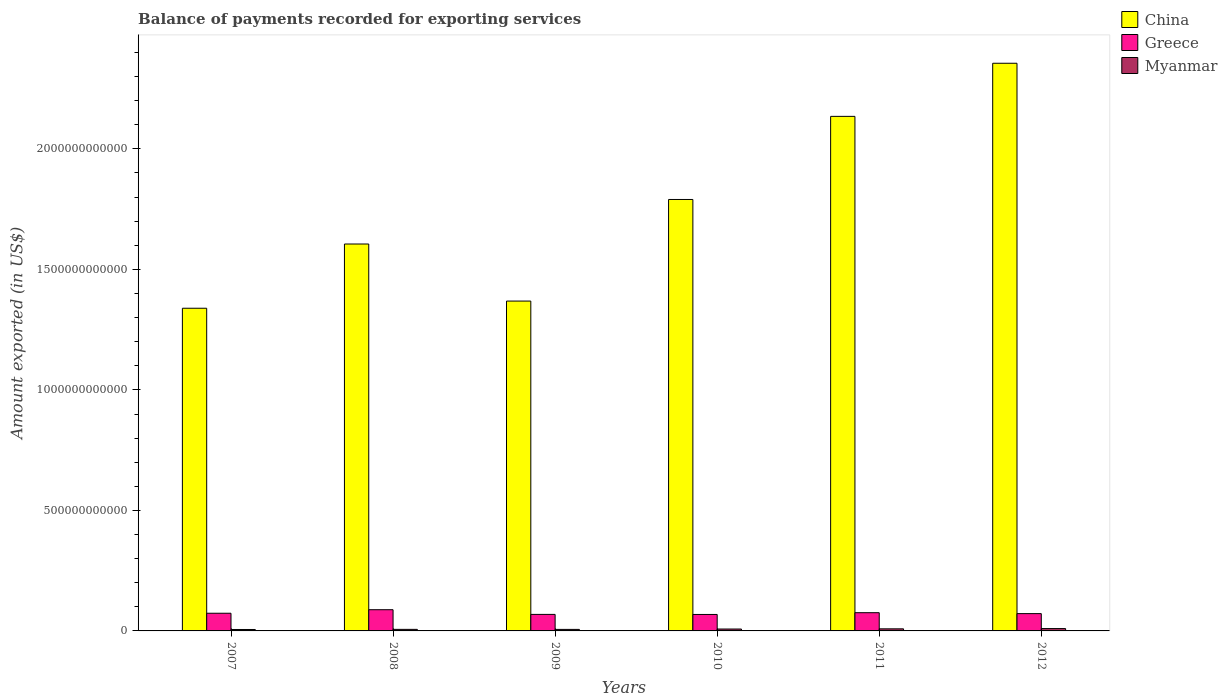Are the number of bars per tick equal to the number of legend labels?
Your answer should be compact. Yes. How many bars are there on the 5th tick from the left?
Make the answer very short. 3. What is the label of the 6th group of bars from the left?
Your answer should be compact. 2012. In how many cases, is the number of bars for a given year not equal to the number of legend labels?
Give a very brief answer. 0. What is the amount exported in Greece in 2012?
Ensure brevity in your answer.  7.18e+1. Across all years, what is the maximum amount exported in Greece?
Make the answer very short. 8.80e+1. Across all years, what is the minimum amount exported in China?
Offer a terse response. 1.34e+12. In which year was the amount exported in China maximum?
Keep it short and to the point. 2012. What is the total amount exported in China in the graph?
Your answer should be compact. 1.06e+13. What is the difference between the amount exported in China in 2007 and that in 2008?
Your response must be concise. -2.67e+11. What is the difference between the amount exported in Greece in 2007 and the amount exported in China in 2009?
Offer a very short reply. -1.30e+12. What is the average amount exported in China per year?
Your answer should be very brief. 1.77e+12. In the year 2009, what is the difference between the amount exported in China and amount exported in Greece?
Your answer should be compact. 1.30e+12. In how many years, is the amount exported in Greece greater than 600000000000 US$?
Ensure brevity in your answer.  0. What is the ratio of the amount exported in Greece in 2010 to that in 2011?
Your answer should be compact. 0.9. Is the amount exported in Myanmar in 2011 less than that in 2012?
Make the answer very short. Yes. What is the difference between the highest and the second highest amount exported in Greece?
Provide a short and direct response. 1.24e+1. What is the difference between the highest and the lowest amount exported in China?
Provide a succinct answer. 1.02e+12. In how many years, is the amount exported in China greater than the average amount exported in China taken over all years?
Offer a terse response. 3. What does the 3rd bar from the left in 2012 represents?
Offer a very short reply. Myanmar. What does the 3rd bar from the right in 2007 represents?
Your answer should be very brief. China. Is it the case that in every year, the sum of the amount exported in China and amount exported in Myanmar is greater than the amount exported in Greece?
Ensure brevity in your answer.  Yes. Are all the bars in the graph horizontal?
Make the answer very short. No. What is the difference between two consecutive major ticks on the Y-axis?
Offer a very short reply. 5.00e+11. Are the values on the major ticks of Y-axis written in scientific E-notation?
Your answer should be compact. No. How many legend labels are there?
Give a very brief answer. 3. How are the legend labels stacked?
Your answer should be very brief. Vertical. What is the title of the graph?
Your answer should be very brief. Balance of payments recorded for exporting services. What is the label or title of the X-axis?
Your answer should be very brief. Years. What is the label or title of the Y-axis?
Ensure brevity in your answer.  Amount exported (in US$). What is the Amount exported (in US$) of China in 2007?
Keep it short and to the point. 1.34e+12. What is the Amount exported (in US$) of Greece in 2007?
Keep it short and to the point. 7.34e+1. What is the Amount exported (in US$) of Myanmar in 2007?
Make the answer very short. 5.91e+09. What is the Amount exported (in US$) in China in 2008?
Your answer should be very brief. 1.61e+12. What is the Amount exported (in US$) of Greece in 2008?
Provide a succinct answer. 8.80e+1. What is the Amount exported (in US$) in Myanmar in 2008?
Your answer should be compact. 6.44e+09. What is the Amount exported (in US$) of China in 2009?
Your answer should be very brief. 1.37e+12. What is the Amount exported (in US$) of Greece in 2009?
Offer a very short reply. 6.85e+1. What is the Amount exported (in US$) in Myanmar in 2009?
Your response must be concise. 6.35e+09. What is the Amount exported (in US$) of China in 2010?
Your answer should be very brief. 1.79e+12. What is the Amount exported (in US$) of Greece in 2010?
Give a very brief answer. 6.83e+1. What is the Amount exported (in US$) in Myanmar in 2010?
Your answer should be very brief. 7.85e+09. What is the Amount exported (in US$) of China in 2011?
Your answer should be very brief. 2.13e+12. What is the Amount exported (in US$) in Greece in 2011?
Your answer should be very brief. 7.56e+1. What is the Amount exported (in US$) in Myanmar in 2011?
Make the answer very short. 8.66e+09. What is the Amount exported (in US$) of China in 2012?
Keep it short and to the point. 2.36e+12. What is the Amount exported (in US$) in Greece in 2012?
Offer a terse response. 7.18e+1. What is the Amount exported (in US$) in Myanmar in 2012?
Your response must be concise. 9.74e+09. Across all years, what is the maximum Amount exported (in US$) of China?
Ensure brevity in your answer.  2.36e+12. Across all years, what is the maximum Amount exported (in US$) of Greece?
Give a very brief answer. 8.80e+1. Across all years, what is the maximum Amount exported (in US$) in Myanmar?
Offer a terse response. 9.74e+09. Across all years, what is the minimum Amount exported (in US$) in China?
Provide a succinct answer. 1.34e+12. Across all years, what is the minimum Amount exported (in US$) of Greece?
Give a very brief answer. 6.83e+1. Across all years, what is the minimum Amount exported (in US$) of Myanmar?
Ensure brevity in your answer.  5.91e+09. What is the total Amount exported (in US$) in China in the graph?
Provide a succinct answer. 1.06e+13. What is the total Amount exported (in US$) of Greece in the graph?
Offer a very short reply. 4.46e+11. What is the total Amount exported (in US$) of Myanmar in the graph?
Your response must be concise. 4.50e+1. What is the difference between the Amount exported (in US$) of China in 2007 and that in 2008?
Your response must be concise. -2.67e+11. What is the difference between the Amount exported (in US$) of Greece in 2007 and that in 2008?
Provide a succinct answer. -1.46e+1. What is the difference between the Amount exported (in US$) in Myanmar in 2007 and that in 2008?
Ensure brevity in your answer.  -5.28e+08. What is the difference between the Amount exported (in US$) of China in 2007 and that in 2009?
Your answer should be compact. -2.97e+1. What is the difference between the Amount exported (in US$) in Greece in 2007 and that in 2009?
Your answer should be compact. 4.86e+09. What is the difference between the Amount exported (in US$) of Myanmar in 2007 and that in 2009?
Keep it short and to the point. -4.36e+08. What is the difference between the Amount exported (in US$) in China in 2007 and that in 2010?
Keep it short and to the point. -4.51e+11. What is the difference between the Amount exported (in US$) of Greece in 2007 and that in 2010?
Offer a terse response. 5.07e+09. What is the difference between the Amount exported (in US$) of Myanmar in 2007 and that in 2010?
Give a very brief answer. -1.94e+09. What is the difference between the Amount exported (in US$) of China in 2007 and that in 2011?
Your answer should be compact. -7.96e+11. What is the difference between the Amount exported (in US$) of Greece in 2007 and that in 2011?
Provide a succinct answer. -2.21e+09. What is the difference between the Amount exported (in US$) of Myanmar in 2007 and that in 2011?
Keep it short and to the point. -2.75e+09. What is the difference between the Amount exported (in US$) in China in 2007 and that in 2012?
Offer a terse response. -1.02e+12. What is the difference between the Amount exported (in US$) of Greece in 2007 and that in 2012?
Keep it short and to the point. 1.61e+09. What is the difference between the Amount exported (in US$) of Myanmar in 2007 and that in 2012?
Keep it short and to the point. -3.83e+09. What is the difference between the Amount exported (in US$) in China in 2008 and that in 2009?
Offer a terse response. 2.37e+11. What is the difference between the Amount exported (in US$) in Greece in 2008 and that in 2009?
Offer a terse response. 1.95e+1. What is the difference between the Amount exported (in US$) of Myanmar in 2008 and that in 2009?
Your answer should be very brief. 9.17e+07. What is the difference between the Amount exported (in US$) in China in 2008 and that in 2010?
Ensure brevity in your answer.  -1.85e+11. What is the difference between the Amount exported (in US$) of Greece in 2008 and that in 2010?
Your response must be concise. 1.97e+1. What is the difference between the Amount exported (in US$) of Myanmar in 2008 and that in 2010?
Make the answer very short. -1.41e+09. What is the difference between the Amount exported (in US$) of China in 2008 and that in 2011?
Ensure brevity in your answer.  -5.30e+11. What is the difference between the Amount exported (in US$) in Greece in 2008 and that in 2011?
Make the answer very short. 1.24e+1. What is the difference between the Amount exported (in US$) of Myanmar in 2008 and that in 2011?
Provide a succinct answer. -2.22e+09. What is the difference between the Amount exported (in US$) in China in 2008 and that in 2012?
Your response must be concise. -7.50e+11. What is the difference between the Amount exported (in US$) in Greece in 2008 and that in 2012?
Give a very brief answer. 1.62e+1. What is the difference between the Amount exported (in US$) in Myanmar in 2008 and that in 2012?
Your response must be concise. -3.31e+09. What is the difference between the Amount exported (in US$) in China in 2009 and that in 2010?
Offer a very short reply. -4.22e+11. What is the difference between the Amount exported (in US$) of Greece in 2009 and that in 2010?
Provide a short and direct response. 2.10e+08. What is the difference between the Amount exported (in US$) of Myanmar in 2009 and that in 2010?
Give a very brief answer. -1.50e+09. What is the difference between the Amount exported (in US$) of China in 2009 and that in 2011?
Your answer should be very brief. -7.66e+11. What is the difference between the Amount exported (in US$) in Greece in 2009 and that in 2011?
Your response must be concise. -7.07e+09. What is the difference between the Amount exported (in US$) in Myanmar in 2009 and that in 2011?
Provide a short and direct response. -2.31e+09. What is the difference between the Amount exported (in US$) in China in 2009 and that in 2012?
Make the answer very short. -9.87e+11. What is the difference between the Amount exported (in US$) in Greece in 2009 and that in 2012?
Make the answer very short. -3.25e+09. What is the difference between the Amount exported (in US$) of Myanmar in 2009 and that in 2012?
Ensure brevity in your answer.  -3.40e+09. What is the difference between the Amount exported (in US$) of China in 2010 and that in 2011?
Your answer should be very brief. -3.45e+11. What is the difference between the Amount exported (in US$) of Greece in 2010 and that in 2011?
Your answer should be very brief. -7.28e+09. What is the difference between the Amount exported (in US$) of Myanmar in 2010 and that in 2011?
Offer a terse response. -8.06e+08. What is the difference between the Amount exported (in US$) in China in 2010 and that in 2012?
Your answer should be very brief. -5.65e+11. What is the difference between the Amount exported (in US$) in Greece in 2010 and that in 2012?
Offer a very short reply. -3.46e+09. What is the difference between the Amount exported (in US$) in Myanmar in 2010 and that in 2012?
Give a very brief answer. -1.89e+09. What is the difference between the Amount exported (in US$) of China in 2011 and that in 2012?
Give a very brief answer. -2.20e+11. What is the difference between the Amount exported (in US$) in Greece in 2011 and that in 2012?
Offer a terse response. 3.82e+09. What is the difference between the Amount exported (in US$) in Myanmar in 2011 and that in 2012?
Offer a terse response. -1.09e+09. What is the difference between the Amount exported (in US$) of China in 2007 and the Amount exported (in US$) of Greece in 2008?
Your answer should be very brief. 1.25e+12. What is the difference between the Amount exported (in US$) in China in 2007 and the Amount exported (in US$) in Myanmar in 2008?
Give a very brief answer. 1.33e+12. What is the difference between the Amount exported (in US$) in Greece in 2007 and the Amount exported (in US$) in Myanmar in 2008?
Offer a terse response. 6.69e+1. What is the difference between the Amount exported (in US$) in China in 2007 and the Amount exported (in US$) in Greece in 2009?
Your answer should be compact. 1.27e+12. What is the difference between the Amount exported (in US$) in China in 2007 and the Amount exported (in US$) in Myanmar in 2009?
Provide a short and direct response. 1.33e+12. What is the difference between the Amount exported (in US$) in Greece in 2007 and the Amount exported (in US$) in Myanmar in 2009?
Provide a short and direct response. 6.70e+1. What is the difference between the Amount exported (in US$) in China in 2007 and the Amount exported (in US$) in Greece in 2010?
Keep it short and to the point. 1.27e+12. What is the difference between the Amount exported (in US$) of China in 2007 and the Amount exported (in US$) of Myanmar in 2010?
Give a very brief answer. 1.33e+12. What is the difference between the Amount exported (in US$) in Greece in 2007 and the Amount exported (in US$) in Myanmar in 2010?
Provide a short and direct response. 6.55e+1. What is the difference between the Amount exported (in US$) of China in 2007 and the Amount exported (in US$) of Greece in 2011?
Provide a short and direct response. 1.26e+12. What is the difference between the Amount exported (in US$) of China in 2007 and the Amount exported (in US$) of Myanmar in 2011?
Provide a short and direct response. 1.33e+12. What is the difference between the Amount exported (in US$) in Greece in 2007 and the Amount exported (in US$) in Myanmar in 2011?
Make the answer very short. 6.47e+1. What is the difference between the Amount exported (in US$) in China in 2007 and the Amount exported (in US$) in Greece in 2012?
Your response must be concise. 1.27e+12. What is the difference between the Amount exported (in US$) of China in 2007 and the Amount exported (in US$) of Myanmar in 2012?
Ensure brevity in your answer.  1.33e+12. What is the difference between the Amount exported (in US$) in Greece in 2007 and the Amount exported (in US$) in Myanmar in 2012?
Provide a succinct answer. 6.36e+1. What is the difference between the Amount exported (in US$) of China in 2008 and the Amount exported (in US$) of Greece in 2009?
Your answer should be very brief. 1.54e+12. What is the difference between the Amount exported (in US$) in China in 2008 and the Amount exported (in US$) in Myanmar in 2009?
Keep it short and to the point. 1.60e+12. What is the difference between the Amount exported (in US$) of Greece in 2008 and the Amount exported (in US$) of Myanmar in 2009?
Your answer should be compact. 8.17e+1. What is the difference between the Amount exported (in US$) in China in 2008 and the Amount exported (in US$) in Greece in 2010?
Your response must be concise. 1.54e+12. What is the difference between the Amount exported (in US$) of China in 2008 and the Amount exported (in US$) of Myanmar in 2010?
Your answer should be very brief. 1.60e+12. What is the difference between the Amount exported (in US$) in Greece in 2008 and the Amount exported (in US$) in Myanmar in 2010?
Your answer should be compact. 8.02e+1. What is the difference between the Amount exported (in US$) of China in 2008 and the Amount exported (in US$) of Greece in 2011?
Your response must be concise. 1.53e+12. What is the difference between the Amount exported (in US$) in China in 2008 and the Amount exported (in US$) in Myanmar in 2011?
Your answer should be compact. 1.60e+12. What is the difference between the Amount exported (in US$) of Greece in 2008 and the Amount exported (in US$) of Myanmar in 2011?
Make the answer very short. 7.94e+1. What is the difference between the Amount exported (in US$) of China in 2008 and the Amount exported (in US$) of Greece in 2012?
Your answer should be compact. 1.53e+12. What is the difference between the Amount exported (in US$) in China in 2008 and the Amount exported (in US$) in Myanmar in 2012?
Provide a succinct answer. 1.60e+12. What is the difference between the Amount exported (in US$) in Greece in 2008 and the Amount exported (in US$) in Myanmar in 2012?
Give a very brief answer. 7.83e+1. What is the difference between the Amount exported (in US$) of China in 2009 and the Amount exported (in US$) of Greece in 2010?
Your response must be concise. 1.30e+12. What is the difference between the Amount exported (in US$) of China in 2009 and the Amount exported (in US$) of Myanmar in 2010?
Make the answer very short. 1.36e+12. What is the difference between the Amount exported (in US$) of Greece in 2009 and the Amount exported (in US$) of Myanmar in 2010?
Offer a terse response. 6.07e+1. What is the difference between the Amount exported (in US$) in China in 2009 and the Amount exported (in US$) in Greece in 2011?
Provide a short and direct response. 1.29e+12. What is the difference between the Amount exported (in US$) of China in 2009 and the Amount exported (in US$) of Myanmar in 2011?
Give a very brief answer. 1.36e+12. What is the difference between the Amount exported (in US$) in Greece in 2009 and the Amount exported (in US$) in Myanmar in 2011?
Give a very brief answer. 5.99e+1. What is the difference between the Amount exported (in US$) of China in 2009 and the Amount exported (in US$) of Greece in 2012?
Ensure brevity in your answer.  1.30e+12. What is the difference between the Amount exported (in US$) of China in 2009 and the Amount exported (in US$) of Myanmar in 2012?
Ensure brevity in your answer.  1.36e+12. What is the difference between the Amount exported (in US$) in Greece in 2009 and the Amount exported (in US$) in Myanmar in 2012?
Your answer should be compact. 5.88e+1. What is the difference between the Amount exported (in US$) of China in 2010 and the Amount exported (in US$) of Greece in 2011?
Provide a succinct answer. 1.71e+12. What is the difference between the Amount exported (in US$) of China in 2010 and the Amount exported (in US$) of Myanmar in 2011?
Your response must be concise. 1.78e+12. What is the difference between the Amount exported (in US$) of Greece in 2010 and the Amount exported (in US$) of Myanmar in 2011?
Your answer should be compact. 5.97e+1. What is the difference between the Amount exported (in US$) of China in 2010 and the Amount exported (in US$) of Greece in 2012?
Ensure brevity in your answer.  1.72e+12. What is the difference between the Amount exported (in US$) in China in 2010 and the Amount exported (in US$) in Myanmar in 2012?
Give a very brief answer. 1.78e+12. What is the difference between the Amount exported (in US$) of Greece in 2010 and the Amount exported (in US$) of Myanmar in 2012?
Ensure brevity in your answer.  5.86e+1. What is the difference between the Amount exported (in US$) in China in 2011 and the Amount exported (in US$) in Greece in 2012?
Make the answer very short. 2.06e+12. What is the difference between the Amount exported (in US$) in China in 2011 and the Amount exported (in US$) in Myanmar in 2012?
Make the answer very short. 2.13e+12. What is the difference between the Amount exported (in US$) in Greece in 2011 and the Amount exported (in US$) in Myanmar in 2012?
Make the answer very short. 6.58e+1. What is the average Amount exported (in US$) in China per year?
Your response must be concise. 1.77e+12. What is the average Amount exported (in US$) of Greece per year?
Your response must be concise. 7.43e+1. What is the average Amount exported (in US$) of Myanmar per year?
Offer a terse response. 7.49e+09. In the year 2007, what is the difference between the Amount exported (in US$) of China and Amount exported (in US$) of Greece?
Provide a succinct answer. 1.27e+12. In the year 2007, what is the difference between the Amount exported (in US$) in China and Amount exported (in US$) in Myanmar?
Your response must be concise. 1.33e+12. In the year 2007, what is the difference between the Amount exported (in US$) in Greece and Amount exported (in US$) in Myanmar?
Ensure brevity in your answer.  6.75e+1. In the year 2008, what is the difference between the Amount exported (in US$) of China and Amount exported (in US$) of Greece?
Your response must be concise. 1.52e+12. In the year 2008, what is the difference between the Amount exported (in US$) in China and Amount exported (in US$) in Myanmar?
Keep it short and to the point. 1.60e+12. In the year 2008, what is the difference between the Amount exported (in US$) in Greece and Amount exported (in US$) in Myanmar?
Offer a terse response. 8.16e+1. In the year 2009, what is the difference between the Amount exported (in US$) in China and Amount exported (in US$) in Greece?
Offer a very short reply. 1.30e+12. In the year 2009, what is the difference between the Amount exported (in US$) in China and Amount exported (in US$) in Myanmar?
Provide a succinct answer. 1.36e+12. In the year 2009, what is the difference between the Amount exported (in US$) in Greece and Amount exported (in US$) in Myanmar?
Your answer should be very brief. 6.22e+1. In the year 2010, what is the difference between the Amount exported (in US$) of China and Amount exported (in US$) of Greece?
Your response must be concise. 1.72e+12. In the year 2010, what is the difference between the Amount exported (in US$) in China and Amount exported (in US$) in Myanmar?
Give a very brief answer. 1.78e+12. In the year 2010, what is the difference between the Amount exported (in US$) in Greece and Amount exported (in US$) in Myanmar?
Provide a short and direct response. 6.05e+1. In the year 2011, what is the difference between the Amount exported (in US$) of China and Amount exported (in US$) of Greece?
Offer a very short reply. 2.06e+12. In the year 2011, what is the difference between the Amount exported (in US$) of China and Amount exported (in US$) of Myanmar?
Offer a terse response. 2.13e+12. In the year 2011, what is the difference between the Amount exported (in US$) of Greece and Amount exported (in US$) of Myanmar?
Offer a very short reply. 6.69e+1. In the year 2012, what is the difference between the Amount exported (in US$) in China and Amount exported (in US$) in Greece?
Your answer should be very brief. 2.28e+12. In the year 2012, what is the difference between the Amount exported (in US$) of China and Amount exported (in US$) of Myanmar?
Offer a terse response. 2.35e+12. In the year 2012, what is the difference between the Amount exported (in US$) of Greece and Amount exported (in US$) of Myanmar?
Provide a short and direct response. 6.20e+1. What is the ratio of the Amount exported (in US$) in China in 2007 to that in 2008?
Give a very brief answer. 0.83. What is the ratio of the Amount exported (in US$) in Greece in 2007 to that in 2008?
Ensure brevity in your answer.  0.83. What is the ratio of the Amount exported (in US$) in Myanmar in 2007 to that in 2008?
Provide a succinct answer. 0.92. What is the ratio of the Amount exported (in US$) in China in 2007 to that in 2009?
Offer a very short reply. 0.98. What is the ratio of the Amount exported (in US$) in Greece in 2007 to that in 2009?
Your response must be concise. 1.07. What is the ratio of the Amount exported (in US$) in Myanmar in 2007 to that in 2009?
Your answer should be very brief. 0.93. What is the ratio of the Amount exported (in US$) of China in 2007 to that in 2010?
Provide a short and direct response. 0.75. What is the ratio of the Amount exported (in US$) of Greece in 2007 to that in 2010?
Make the answer very short. 1.07. What is the ratio of the Amount exported (in US$) in Myanmar in 2007 to that in 2010?
Provide a succinct answer. 0.75. What is the ratio of the Amount exported (in US$) of China in 2007 to that in 2011?
Your answer should be compact. 0.63. What is the ratio of the Amount exported (in US$) in Greece in 2007 to that in 2011?
Offer a terse response. 0.97. What is the ratio of the Amount exported (in US$) in Myanmar in 2007 to that in 2011?
Your answer should be very brief. 0.68. What is the ratio of the Amount exported (in US$) of China in 2007 to that in 2012?
Ensure brevity in your answer.  0.57. What is the ratio of the Amount exported (in US$) in Greece in 2007 to that in 2012?
Offer a terse response. 1.02. What is the ratio of the Amount exported (in US$) of Myanmar in 2007 to that in 2012?
Offer a terse response. 0.61. What is the ratio of the Amount exported (in US$) in China in 2008 to that in 2009?
Offer a terse response. 1.17. What is the ratio of the Amount exported (in US$) in Greece in 2008 to that in 2009?
Your answer should be compact. 1.28. What is the ratio of the Amount exported (in US$) of Myanmar in 2008 to that in 2009?
Offer a terse response. 1.01. What is the ratio of the Amount exported (in US$) in China in 2008 to that in 2010?
Make the answer very short. 0.9. What is the ratio of the Amount exported (in US$) of Greece in 2008 to that in 2010?
Offer a terse response. 1.29. What is the ratio of the Amount exported (in US$) of Myanmar in 2008 to that in 2010?
Your response must be concise. 0.82. What is the ratio of the Amount exported (in US$) of China in 2008 to that in 2011?
Offer a very short reply. 0.75. What is the ratio of the Amount exported (in US$) of Greece in 2008 to that in 2011?
Make the answer very short. 1.16. What is the ratio of the Amount exported (in US$) of Myanmar in 2008 to that in 2011?
Make the answer very short. 0.74. What is the ratio of the Amount exported (in US$) in China in 2008 to that in 2012?
Offer a terse response. 0.68. What is the ratio of the Amount exported (in US$) of Greece in 2008 to that in 2012?
Keep it short and to the point. 1.23. What is the ratio of the Amount exported (in US$) of Myanmar in 2008 to that in 2012?
Provide a short and direct response. 0.66. What is the ratio of the Amount exported (in US$) of China in 2009 to that in 2010?
Your answer should be very brief. 0.76. What is the ratio of the Amount exported (in US$) in Myanmar in 2009 to that in 2010?
Your answer should be very brief. 0.81. What is the ratio of the Amount exported (in US$) in China in 2009 to that in 2011?
Make the answer very short. 0.64. What is the ratio of the Amount exported (in US$) of Greece in 2009 to that in 2011?
Your answer should be compact. 0.91. What is the ratio of the Amount exported (in US$) in Myanmar in 2009 to that in 2011?
Ensure brevity in your answer.  0.73. What is the ratio of the Amount exported (in US$) of China in 2009 to that in 2012?
Ensure brevity in your answer.  0.58. What is the ratio of the Amount exported (in US$) of Greece in 2009 to that in 2012?
Offer a very short reply. 0.95. What is the ratio of the Amount exported (in US$) of Myanmar in 2009 to that in 2012?
Offer a very short reply. 0.65. What is the ratio of the Amount exported (in US$) in China in 2010 to that in 2011?
Your answer should be very brief. 0.84. What is the ratio of the Amount exported (in US$) in Greece in 2010 to that in 2011?
Ensure brevity in your answer.  0.9. What is the ratio of the Amount exported (in US$) in Myanmar in 2010 to that in 2011?
Offer a terse response. 0.91. What is the ratio of the Amount exported (in US$) of China in 2010 to that in 2012?
Your answer should be compact. 0.76. What is the ratio of the Amount exported (in US$) of Greece in 2010 to that in 2012?
Your response must be concise. 0.95. What is the ratio of the Amount exported (in US$) in Myanmar in 2010 to that in 2012?
Your answer should be compact. 0.81. What is the ratio of the Amount exported (in US$) of China in 2011 to that in 2012?
Make the answer very short. 0.91. What is the ratio of the Amount exported (in US$) in Greece in 2011 to that in 2012?
Your answer should be compact. 1.05. What is the ratio of the Amount exported (in US$) in Myanmar in 2011 to that in 2012?
Provide a succinct answer. 0.89. What is the difference between the highest and the second highest Amount exported (in US$) in China?
Offer a very short reply. 2.20e+11. What is the difference between the highest and the second highest Amount exported (in US$) in Greece?
Your answer should be very brief. 1.24e+1. What is the difference between the highest and the second highest Amount exported (in US$) of Myanmar?
Provide a short and direct response. 1.09e+09. What is the difference between the highest and the lowest Amount exported (in US$) of China?
Your answer should be very brief. 1.02e+12. What is the difference between the highest and the lowest Amount exported (in US$) in Greece?
Your answer should be very brief. 1.97e+1. What is the difference between the highest and the lowest Amount exported (in US$) of Myanmar?
Provide a succinct answer. 3.83e+09. 